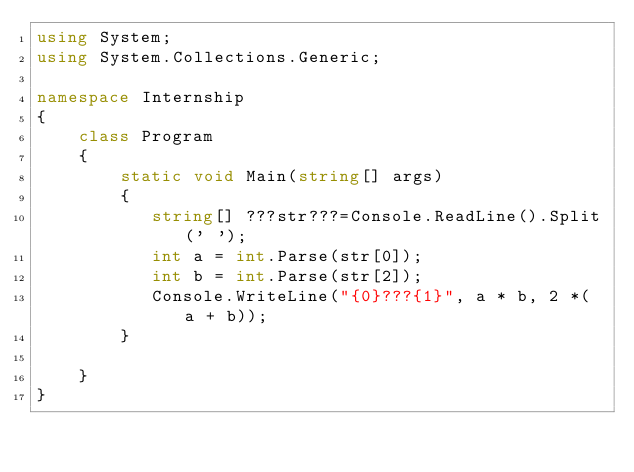<code> <loc_0><loc_0><loc_500><loc_500><_C#_>using System;
using System.Collections.Generic;

namespace Internship
{
    class Program
    {
        static void Main(string[] args)
        {
           string[] ???str???=Console.ReadLine().Split(' ');
           int a = int.Parse(str[0]);
           int b = int.Parse(str[2]);
           Console.WriteLine("{0}???{1}", a * b, 2 *( a + b));
        }

    }
}</code> 